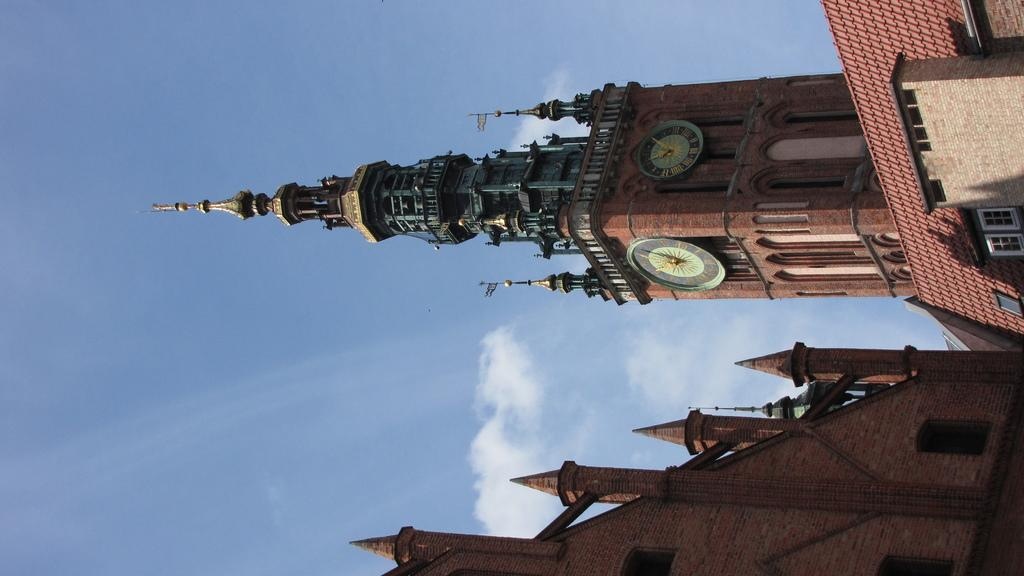What type of structures can be seen in the image? There are buildings in the image. What feature is common to the buildings in the image? There are windows in the buildings. What can be found inside the buildings? There are clocks in the buildings. What is visible in the background of the image? The sky is visible in the background of the image. What can be observed in the sky? Clouds are present in the sky. What type of creature can be seen at the zoo in the image? There is no zoo or creature present in the image; it features buildings with windows and clocks, and a sky with clouds. What time is it in the image? The image does not provide any information about the time; it only shows buildings, windows, clocks, and a sky with clouds. 